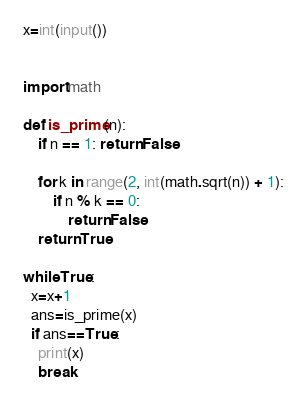<code> <loc_0><loc_0><loc_500><loc_500><_Python_>x=int(input())

 
import math

def is_prime(n):
    if n == 1: return False

    for k in range(2, int(math.sqrt(n)) + 1):
        if n % k == 0:
            return False
    return True

while True:
  x=x+1
  ans=is_prime(x)
  if ans==True:
    print(x)
    break</code> 